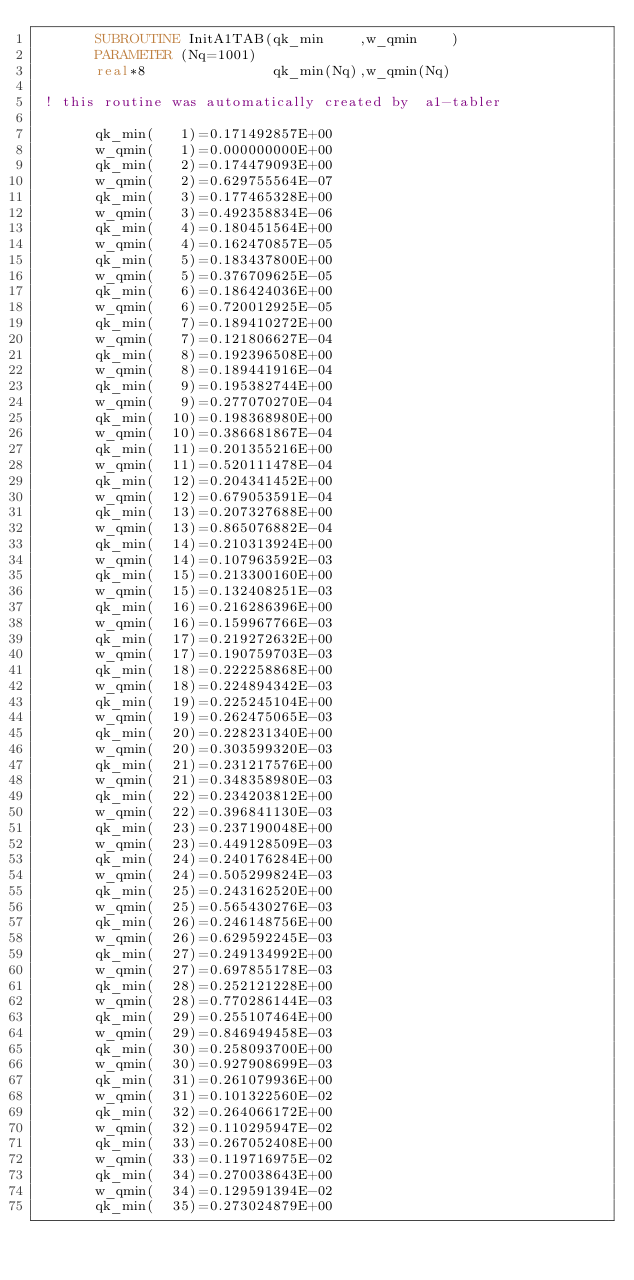<code> <loc_0><loc_0><loc_500><loc_500><_FORTRAN_>       SUBROUTINE InitA1TAB(qk_min    ,w_qmin    )
       PARAMETER (Nq=1001)    
       real*8               qk_min(Nq),w_qmin(Nq)
   
 ! this routine was automatically created by  a1-tabler
   
       qk_min(   1)=0.171492857E+00
       w_qmin(   1)=0.000000000E+00
       qk_min(   2)=0.174479093E+00
       w_qmin(   2)=0.629755564E-07
       qk_min(   3)=0.177465328E+00
       w_qmin(   3)=0.492358834E-06
       qk_min(   4)=0.180451564E+00
       w_qmin(   4)=0.162470857E-05
       qk_min(   5)=0.183437800E+00
       w_qmin(   5)=0.376709625E-05
       qk_min(   6)=0.186424036E+00
       w_qmin(   6)=0.720012925E-05
       qk_min(   7)=0.189410272E+00
       w_qmin(   7)=0.121806627E-04
       qk_min(   8)=0.192396508E+00
       w_qmin(   8)=0.189441916E-04
       qk_min(   9)=0.195382744E+00
       w_qmin(   9)=0.277070270E-04
       qk_min(  10)=0.198368980E+00
       w_qmin(  10)=0.386681867E-04
       qk_min(  11)=0.201355216E+00
       w_qmin(  11)=0.520111478E-04
       qk_min(  12)=0.204341452E+00
       w_qmin(  12)=0.679053591E-04
       qk_min(  13)=0.207327688E+00
       w_qmin(  13)=0.865076882E-04
       qk_min(  14)=0.210313924E+00
       w_qmin(  14)=0.107963592E-03
       qk_min(  15)=0.213300160E+00
       w_qmin(  15)=0.132408251E-03
       qk_min(  16)=0.216286396E+00
       w_qmin(  16)=0.159967766E-03
       qk_min(  17)=0.219272632E+00
       w_qmin(  17)=0.190759703E-03
       qk_min(  18)=0.222258868E+00
       w_qmin(  18)=0.224894342E-03
       qk_min(  19)=0.225245104E+00
       w_qmin(  19)=0.262475065E-03
       qk_min(  20)=0.228231340E+00
       w_qmin(  20)=0.303599320E-03
       qk_min(  21)=0.231217576E+00
       w_qmin(  21)=0.348358980E-03
       qk_min(  22)=0.234203812E+00
       w_qmin(  22)=0.396841130E-03
       qk_min(  23)=0.237190048E+00
       w_qmin(  23)=0.449128509E-03
       qk_min(  24)=0.240176284E+00
       w_qmin(  24)=0.505299824E-03
       qk_min(  25)=0.243162520E+00
       w_qmin(  25)=0.565430276E-03
       qk_min(  26)=0.246148756E+00
       w_qmin(  26)=0.629592245E-03
       qk_min(  27)=0.249134992E+00
       w_qmin(  27)=0.697855178E-03
       qk_min(  28)=0.252121228E+00
       w_qmin(  28)=0.770286144E-03
       qk_min(  29)=0.255107464E+00
       w_qmin(  29)=0.846949458E-03
       qk_min(  30)=0.258093700E+00
       w_qmin(  30)=0.927908699E-03
       qk_min(  31)=0.261079936E+00
       w_qmin(  31)=0.101322560E-02
       qk_min(  32)=0.264066172E+00
       w_qmin(  32)=0.110295947E-02
       qk_min(  33)=0.267052408E+00
       w_qmin(  33)=0.119716975E-02
       qk_min(  34)=0.270038643E+00
       w_qmin(  34)=0.129591394E-02
       qk_min(  35)=0.273024879E+00</code> 